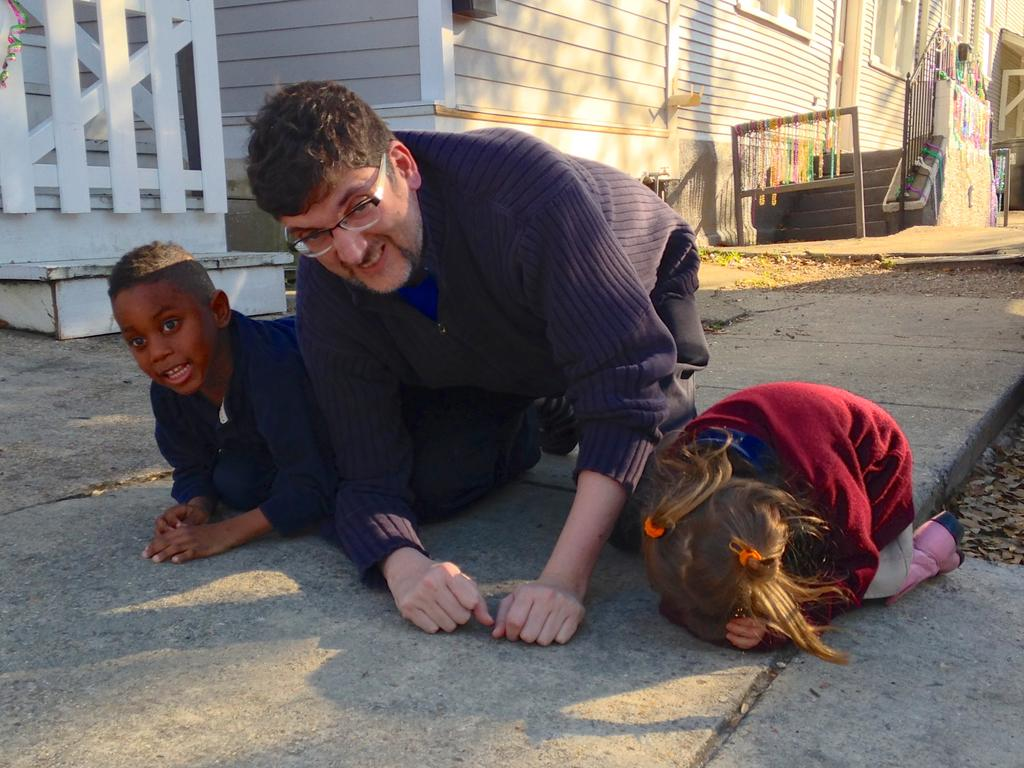Who or what can be seen in the image? There are people in the image. What type of natural elements are visible in the image? Leaves are visible in the image. What architectural feature is present in the image? There is a railing in the image. What can be seen in the background of the image? In the background of the image, there is a wall, steps, windows, and objects. What type of car is parked near the railing in the image? There is no car present in the image; only people, leaves, a railing, and various background features can be seen. 